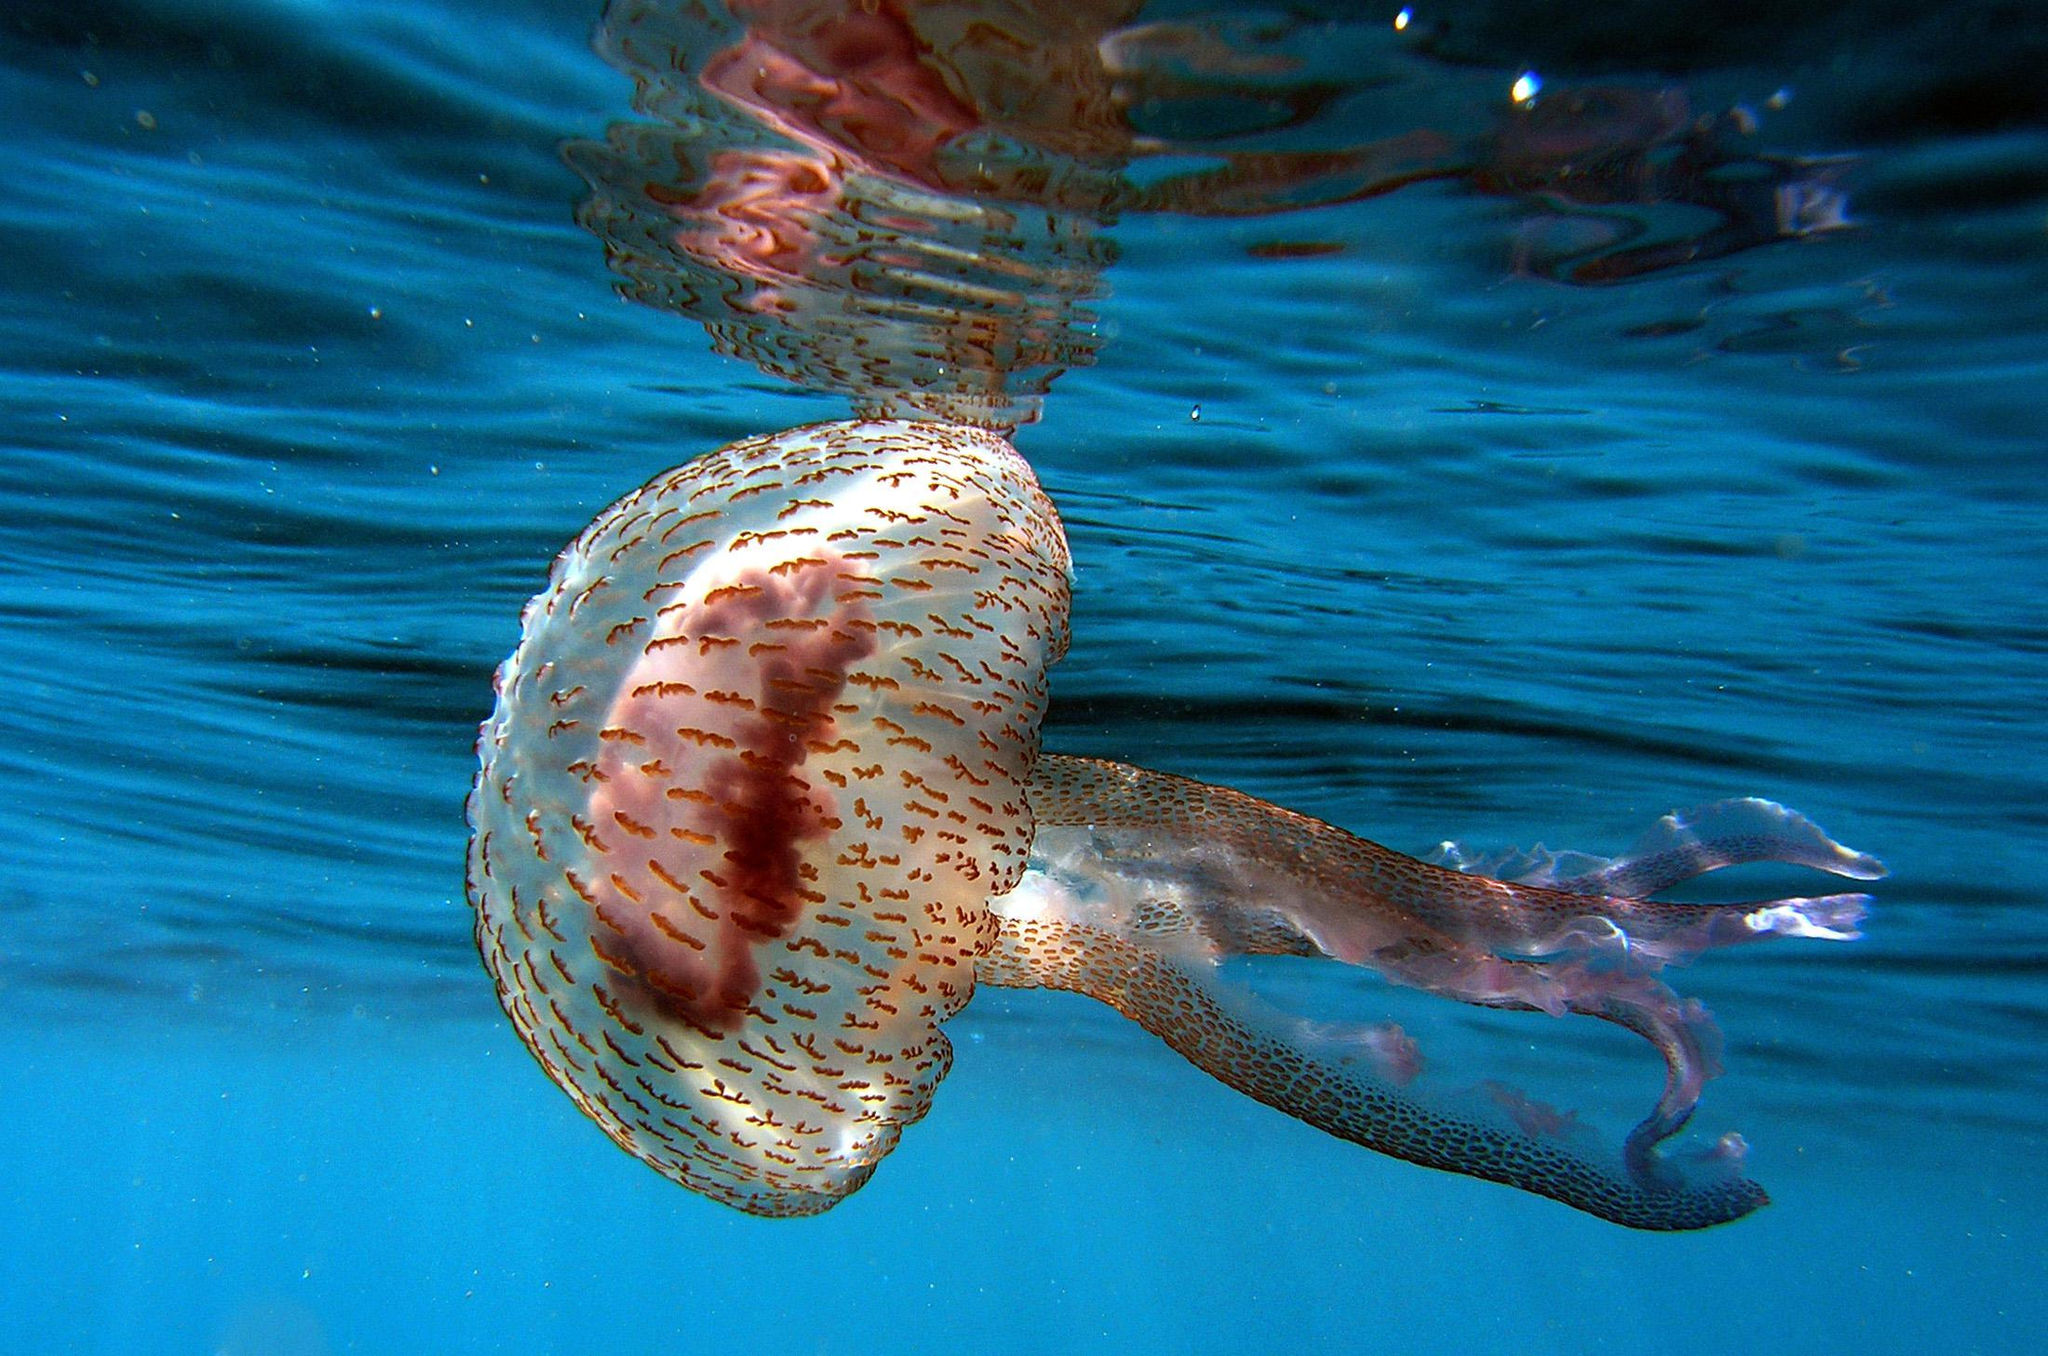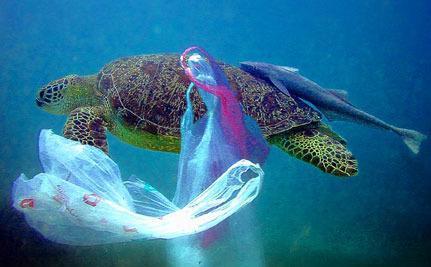The first image is the image on the left, the second image is the image on the right. Considering the images on both sides, is "a turtle is taking a bite of a pink jellyfish" valid? Answer yes or no. No. The first image is the image on the left, the second image is the image on the right. Analyze the images presented: Is the assertion "There are no more than six fish swimming next to a turtle." valid? Answer yes or no. Yes. 